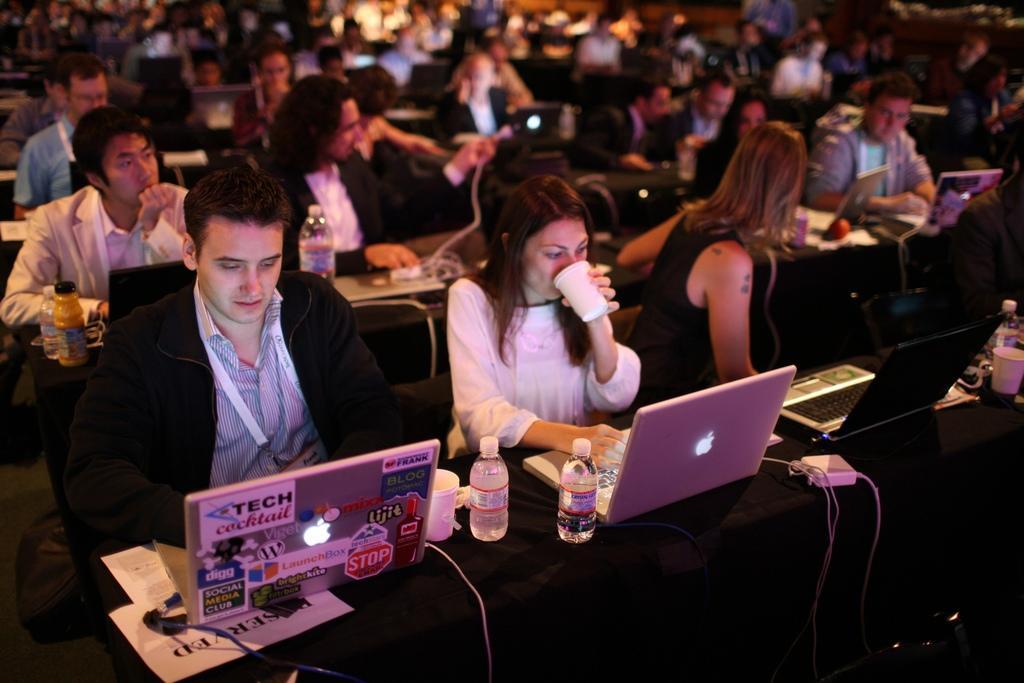How would you summarize this image in a sentence or two? In this image I can see people sitting on chairs in front of tables. On tables I can see laptops, bottles, glasses, wires and other objects. The background of the image is blurred. 